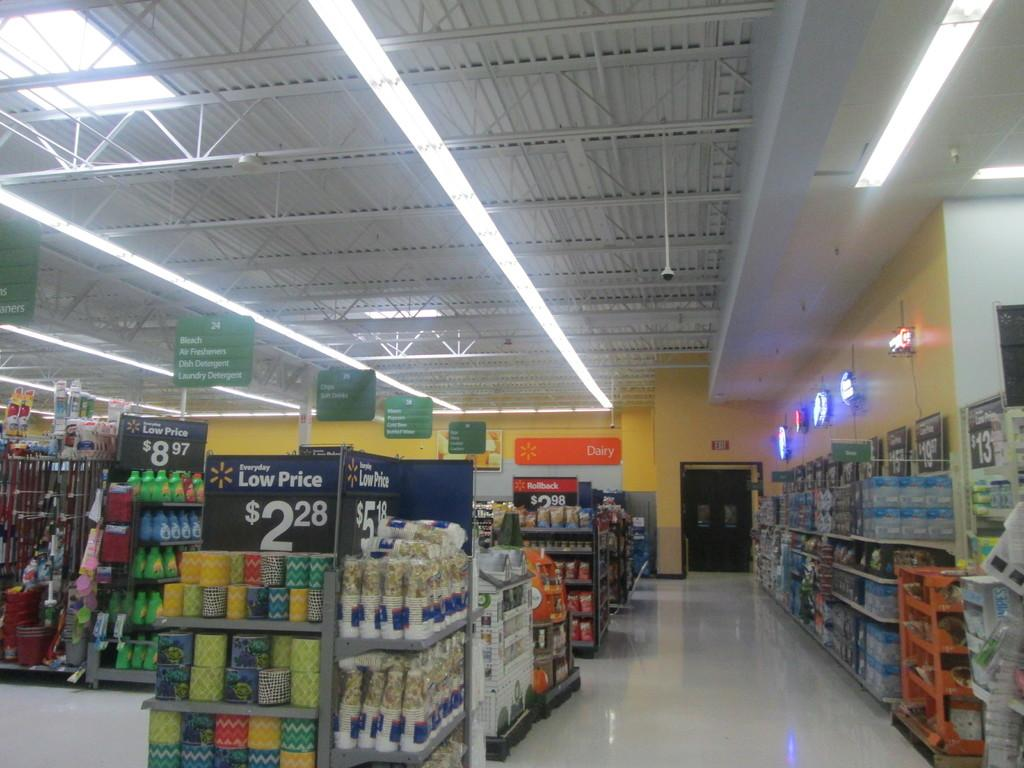<image>
Give a short and clear explanation of the subsequent image. Round boxes of tissues are stacked on a shelf and the sign says they are on sale for $2.28. 